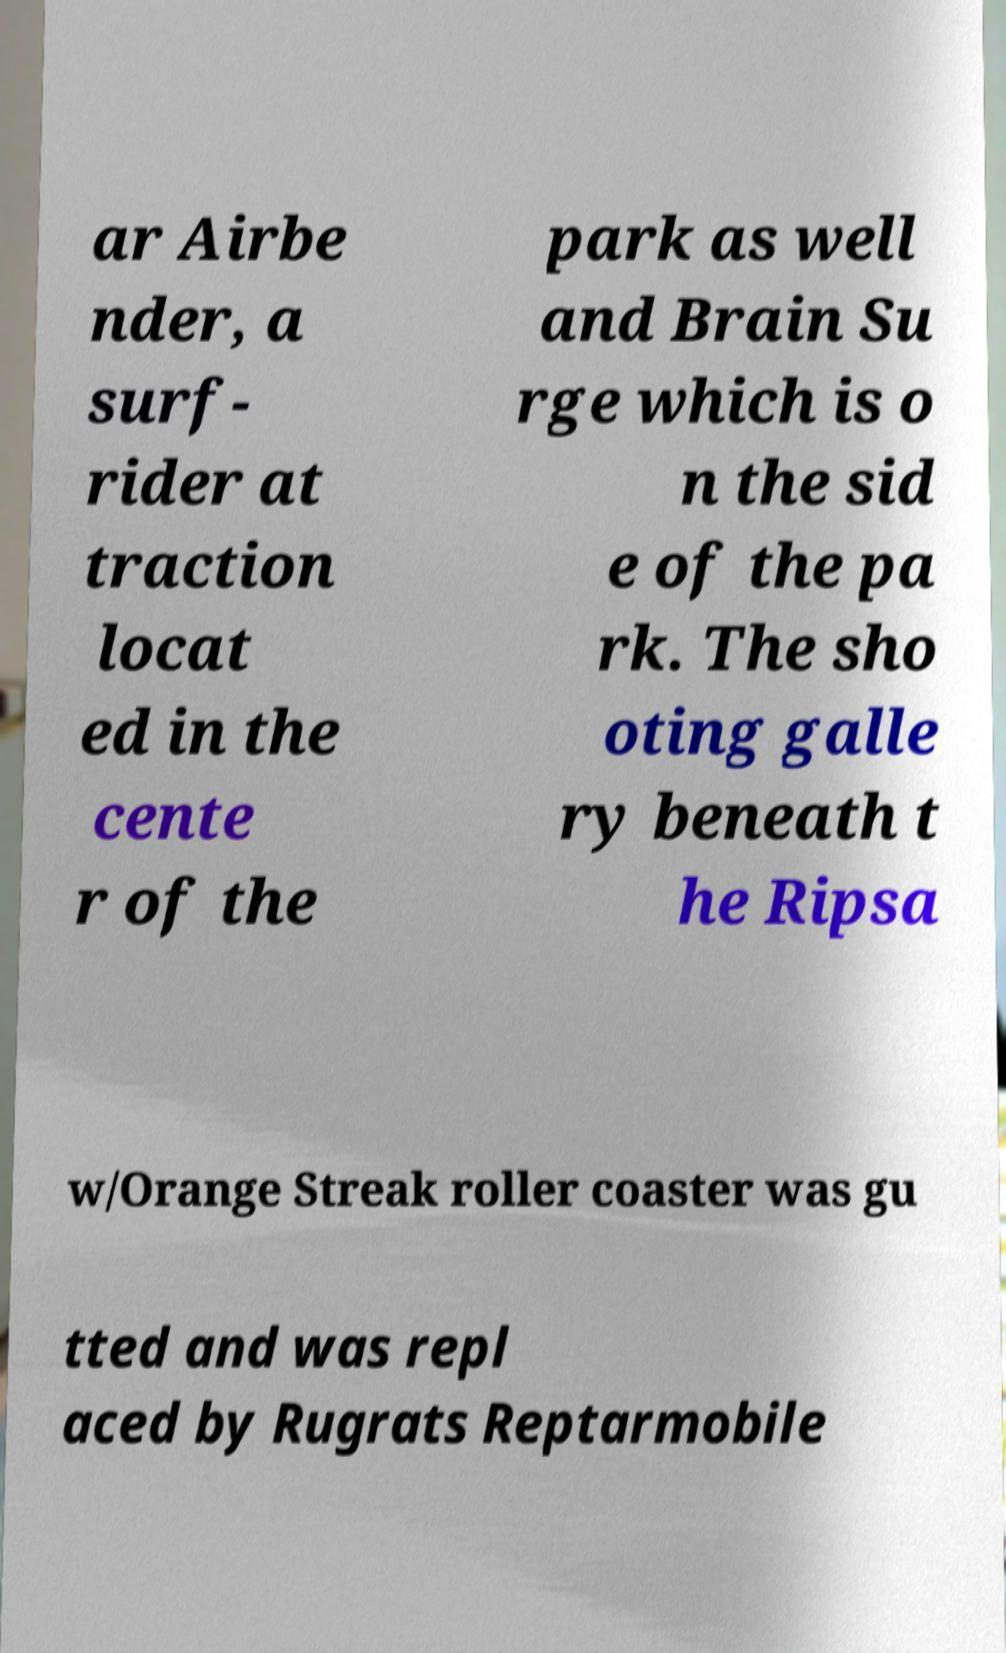For documentation purposes, I need the text within this image transcribed. Could you provide that? ar Airbe nder, a surf- rider at traction locat ed in the cente r of the park as well and Brain Su rge which is o n the sid e of the pa rk. The sho oting galle ry beneath t he Ripsa w/Orange Streak roller coaster was gu tted and was repl aced by Rugrats Reptarmobile 